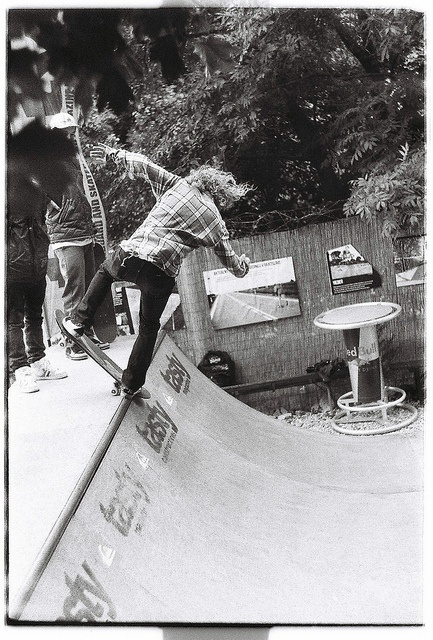Describe the objects in this image and their specific colors. I can see people in white, black, lightgray, gray, and darkgray tones, people in white, black, lightgray, gray, and darkgray tones, people in white, black, gray, and darkgray tones, people in white, gray, black, darkgray, and lightgray tones, and skateboard in white, gray, darkgray, black, and lightgray tones in this image. 